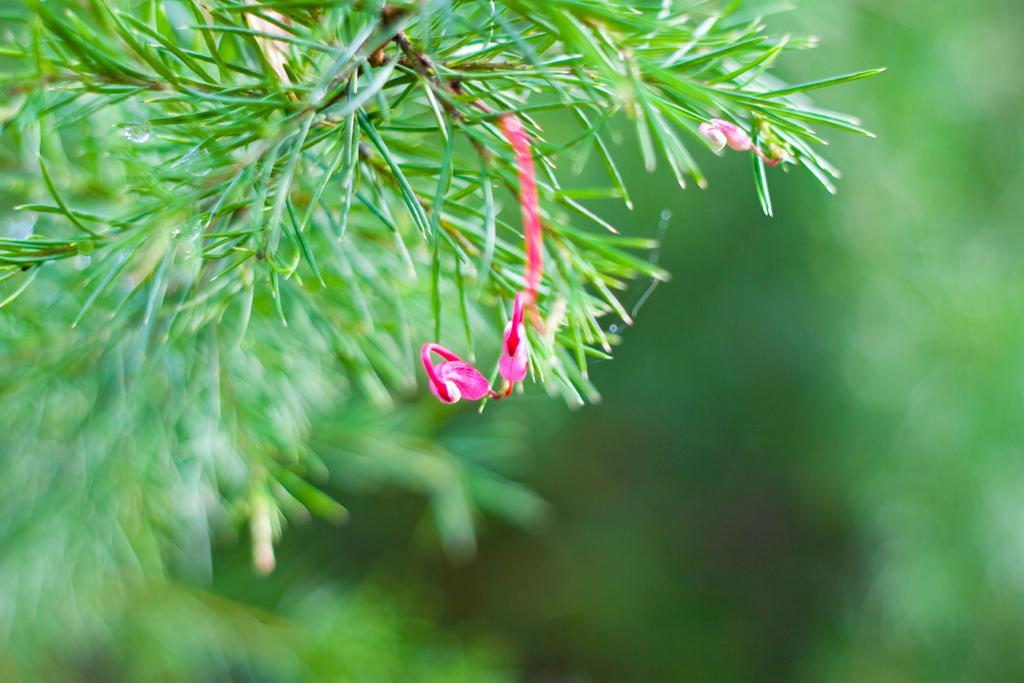How would you summarize this image in a sentence or two? In this picture, we see a tree or a plant. It has flowers and these flowers are in pink color. In the background, it is green in color. This picture is blurred in the background. 